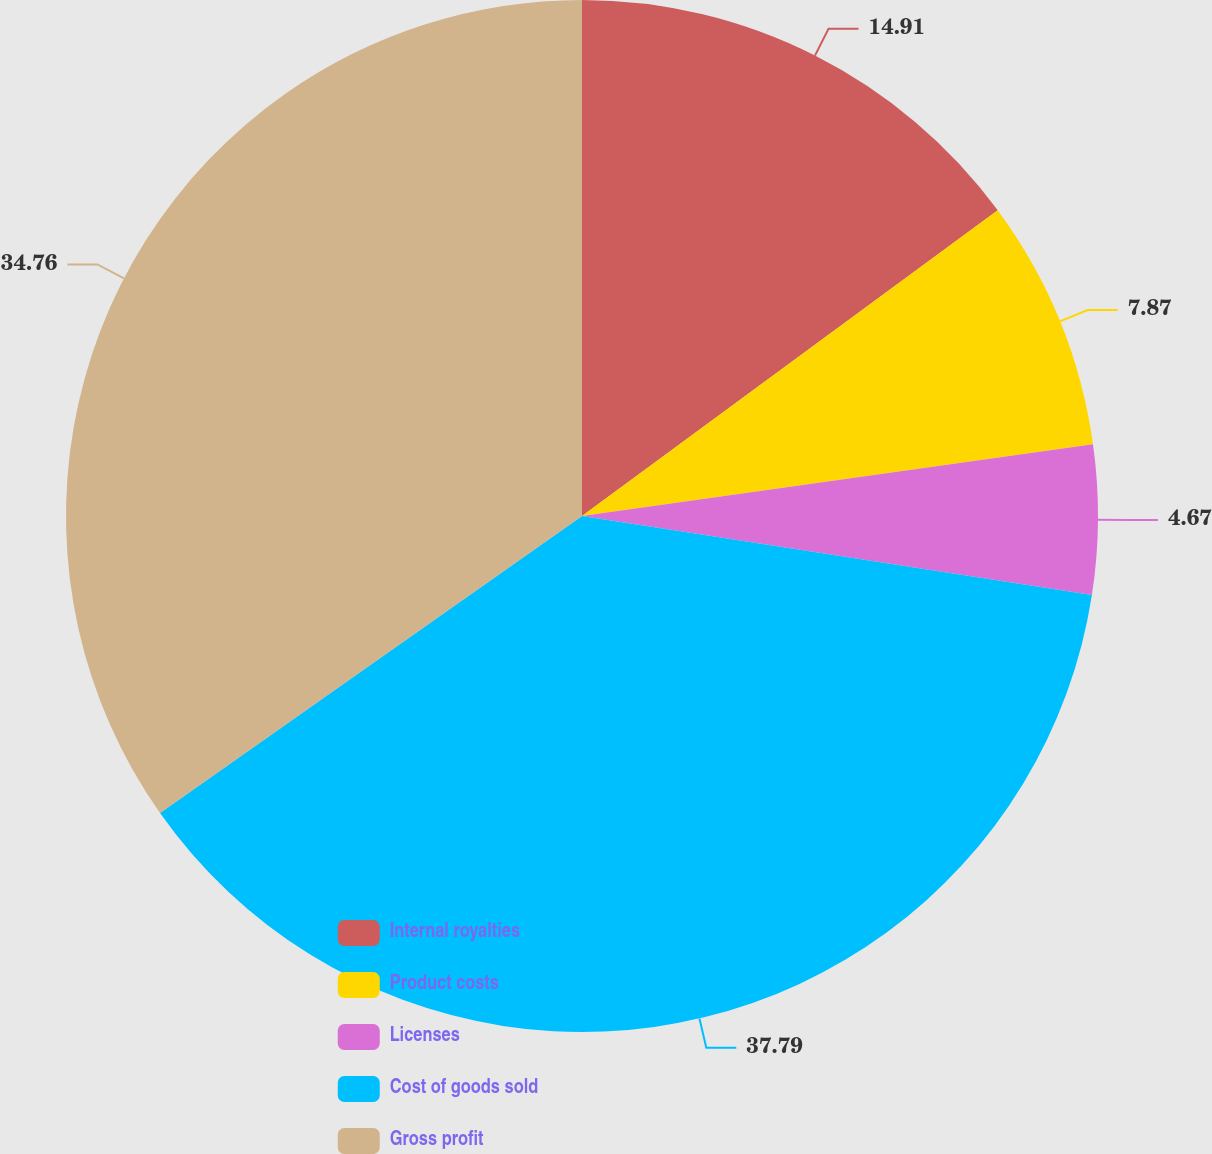<chart> <loc_0><loc_0><loc_500><loc_500><pie_chart><fcel>Internal royalties<fcel>Product costs<fcel>Licenses<fcel>Cost of goods sold<fcel>Gross profit<nl><fcel>14.91%<fcel>7.87%<fcel>4.67%<fcel>37.79%<fcel>34.76%<nl></chart> 